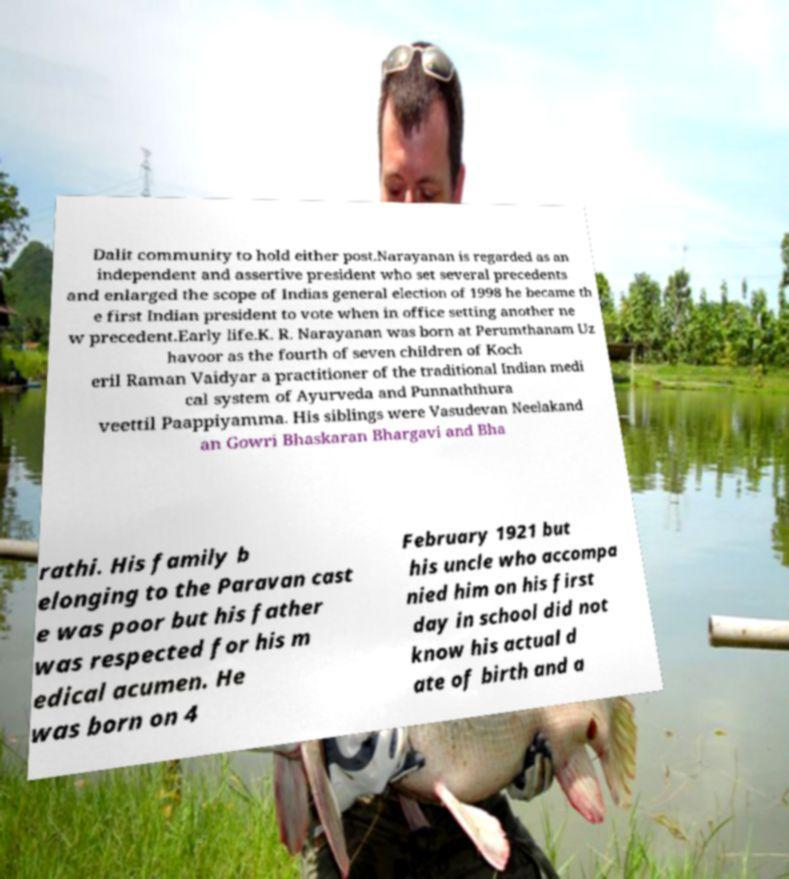Please identify and transcribe the text found in this image. Dalit community to hold either post.Narayanan is regarded as an independent and assertive president who set several precedents and enlarged the scope of Indias general election of 1998 he became th e first Indian president to vote when in office setting another ne w precedent.Early life.K. R. Narayanan was born at Perumthanam Uz havoor as the fourth of seven children of Koch eril Raman Vaidyar a practitioner of the traditional Indian medi cal system of Ayurveda and Punnaththura veettil Paappiyamma. His siblings were Vasudevan Neelakand an Gowri Bhaskaran Bhargavi and Bha rathi. His family b elonging to the Paravan cast e was poor but his father was respected for his m edical acumen. He was born on 4 February 1921 but his uncle who accompa nied him on his first day in school did not know his actual d ate of birth and a 